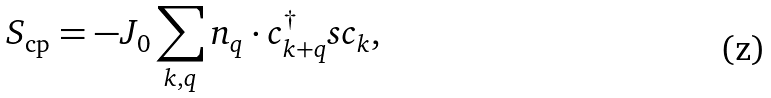<formula> <loc_0><loc_0><loc_500><loc_500>S _ { \text {cp} } = - J _ { 0 } \sum _ { k , q } n _ { q } \cdot c _ { k + q } ^ { \dagger } s c _ { k } ,</formula> 